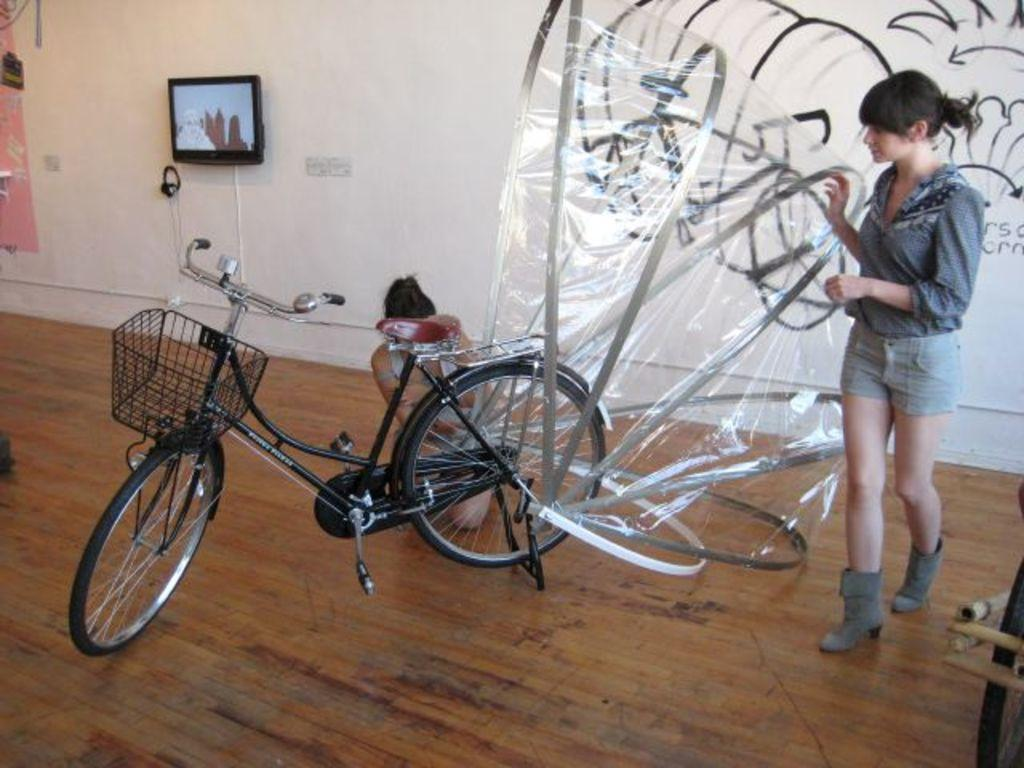How many people are in the image? There are persons in the image, but the exact number cannot be determined from the provided facts. What object related to transportation can be seen in the image? There is a bicycle in the image. What electronic device is present in the image? There is a television in the image. What type of structure is visible in the background of the image? There is a wall in the background of the image. What type of alarm is ringing in the image? There is no alarm present in the image. Can you describe the bath that is visible in the image? There is no bath present in the image. 